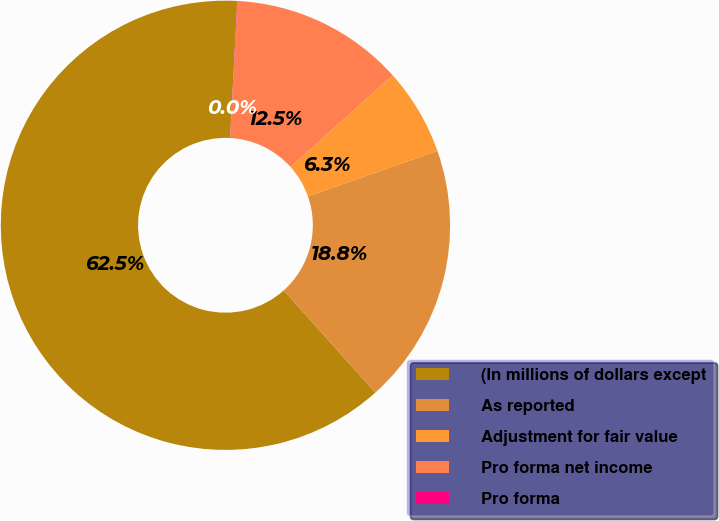Convert chart. <chart><loc_0><loc_0><loc_500><loc_500><pie_chart><fcel>(In millions of dollars except<fcel>As reported<fcel>Adjustment for fair value<fcel>Pro forma net income<fcel>Pro forma<nl><fcel>62.46%<fcel>18.75%<fcel>6.26%<fcel>12.51%<fcel>0.02%<nl></chart> 